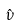Convert formula to latex. <formula><loc_0><loc_0><loc_500><loc_500>\hat { \nu }</formula> 